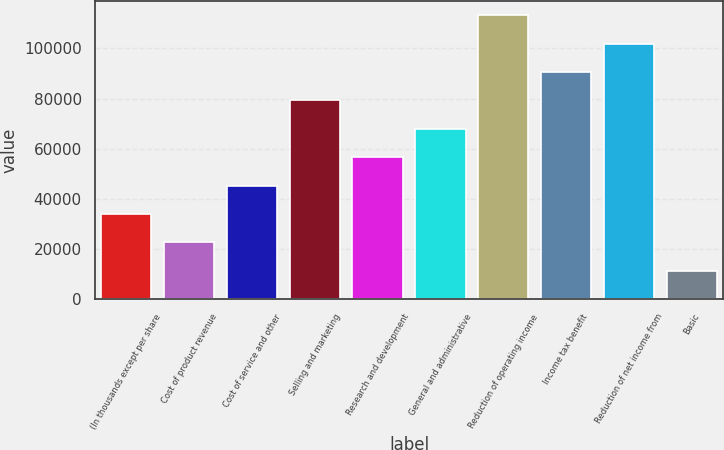Convert chart. <chart><loc_0><loc_0><loc_500><loc_500><bar_chart><fcel>(In thousands except per share<fcel>Cost of product revenue<fcel>Cost of service and other<fcel>Selling and marketing<fcel>Research and development<fcel>General and administrative<fcel>Reduction of operating income<fcel>Income tax benefit<fcel>Reduction of net income from<fcel>Basic<nl><fcel>33971.5<fcel>22647.8<fcel>45295.3<fcel>79266.7<fcel>56619.1<fcel>67942.9<fcel>113238<fcel>90590.4<fcel>101914<fcel>11324<nl></chart> 